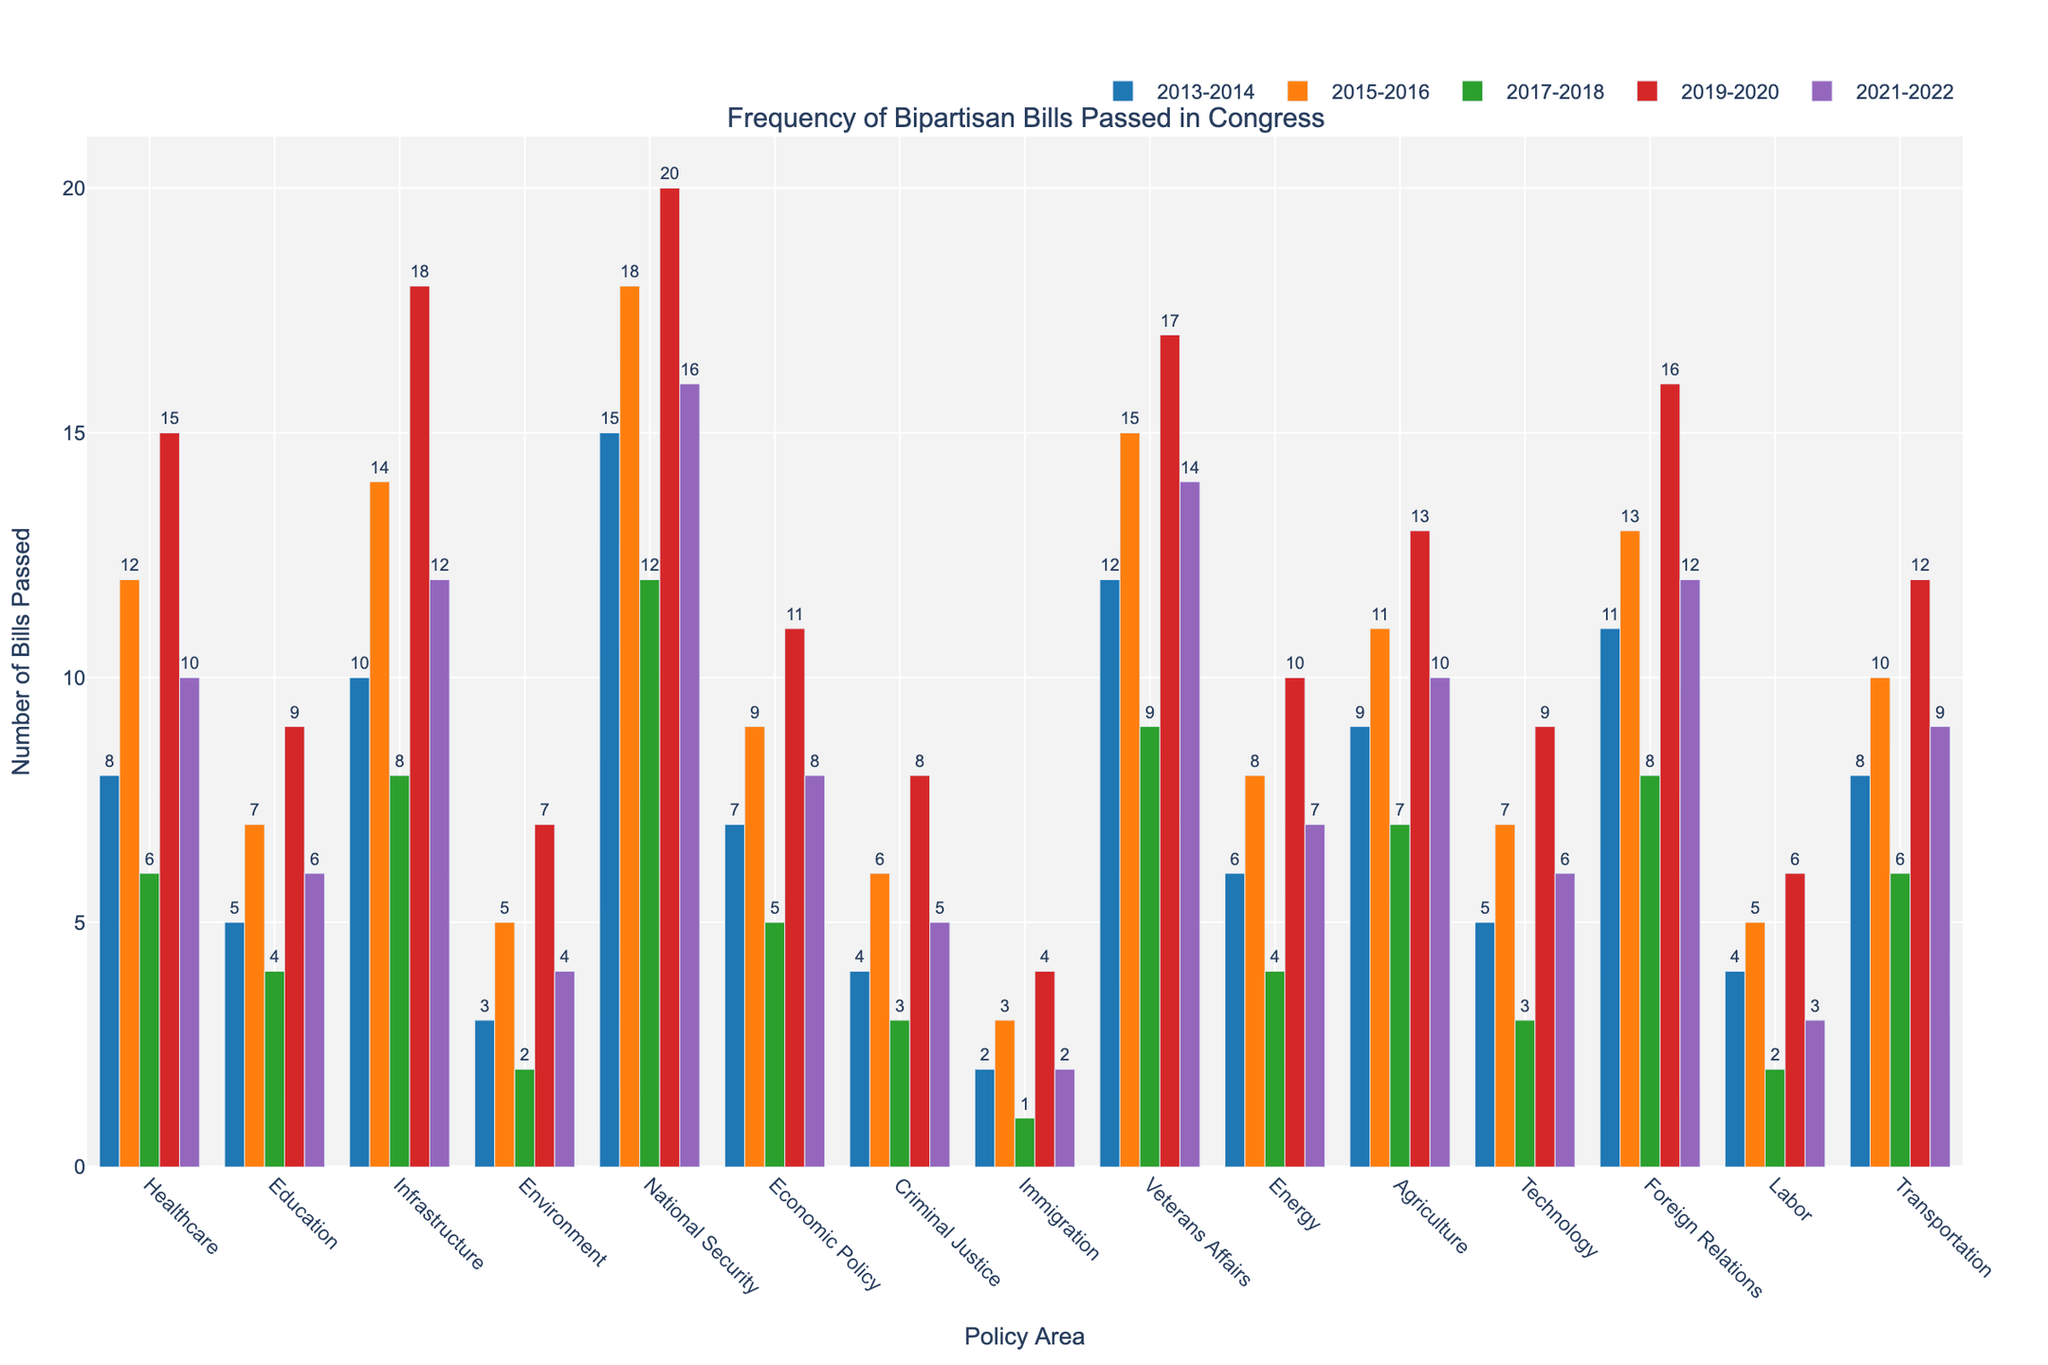Which policy area had the highest number of bipartisan bills passed in 2021-2022? Look for the tallest bar in the 2021-2022 category. National Security has the highest number with 16 bills passed.
Answer: National Security How did the number of bipartisan healthcare bills passed change from 2013-2014 to 2021-2022? Compare the bar heights for Healthcare from 2013-2014 (8 bills) and 2021-2022 (10 bills). There is an increase of 2 bills.
Answer: Increased by 2 Which policy area had the lowest number of bipartisan bills passed in 2017-2018? Identify the shortest bar in the 2017-2018 category. Immigration had the lowest number with 1 bill passed.
Answer: Immigration How many more bipartisan bills were passed in Veterans Affairs compared to Immigration in 2019-2020? Compare the bar heights for Veterans Affairs (17 bills) and Immigration (4 bills) in 2019-2020. The difference is 17 - 4 = 13 bills.
Answer: 13 What is the total number of bipartisan bills passed in Education across all years shown? Sum the number of bills in Education for all years: 5 + 7 + 4 + 9 + 6 = 31
Answer: 31 What is the average number of bipartisan bills passed in Technology from 2013 to 2022? Calculate the average by summing the bills passed in all years for Technology (5 + 7 + 3 + 9 + 6 = 30) and divide by 5 (number of years): 30 / 5 = 6
Answer: 6 Compare the number of bipartisan bills passed in Economic Policy to Healthcare in 2015-2016. Which is higher? Compare the bar heights for Economic Policy (9 bills) and Healthcare (12 bills) in 2015-2016. Healthcare is higher.
Answer: Healthcare Which policy area showed the most significant increase in bipartisan bills from 2017-2018 to 2019-2020? Determine the difference for each policy area between 2017-2018 and 2019-2020. Infrastructure increased the most from 8 to 18 bills (difference of 10).
Answer: Infrastructure What is the median number of bipartisan bills passed in 2019-2020 across all policy areas? List the number of bills for each policy area in 2019-2020, sort them, and find the middle value: [4, 6, 7, 8, 8, 9, 10, 11, 12, 13, 15, 16, 17, 18, 20]. The median is 10.
Answer: 10 